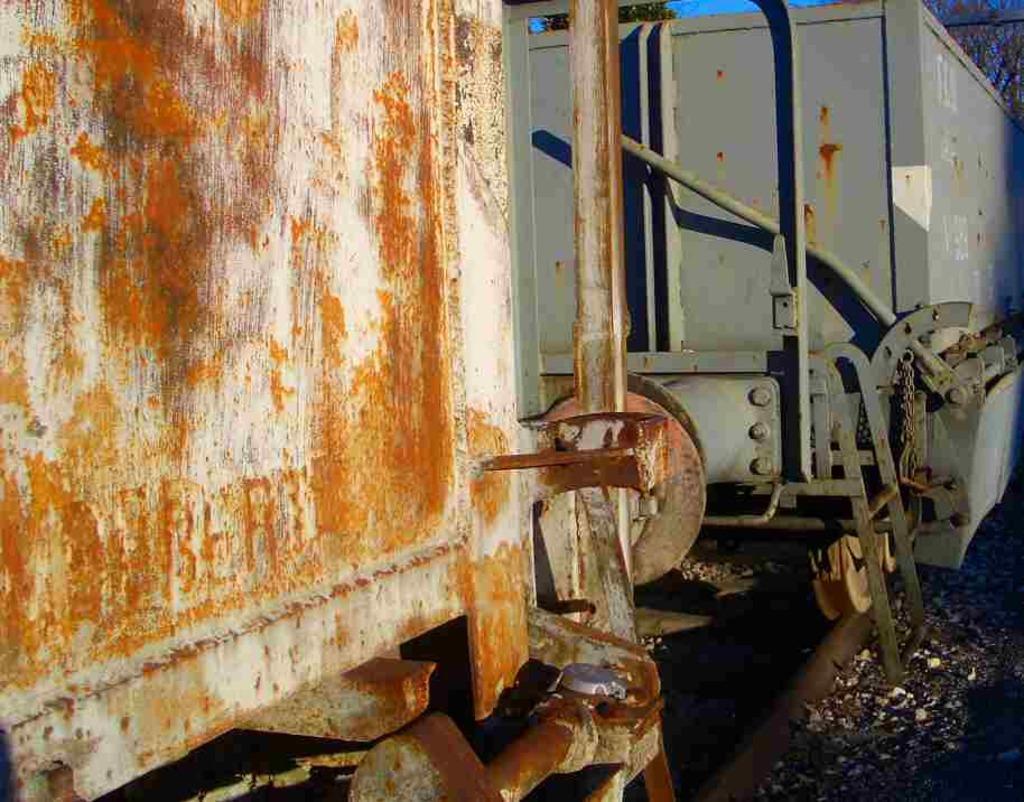Please provide a concise description of this image. In the foreground of this image, it looks like goods carriers of the train on the track. 